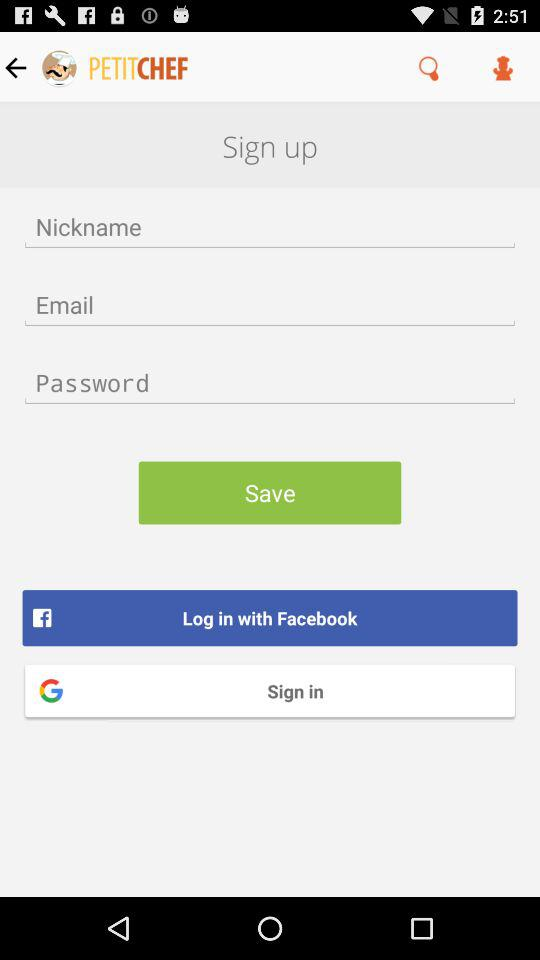What are the requirements to get a login?
When the provided information is insufficient, respond with <no answer>. <no answer> 